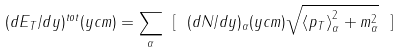Convert formula to latex. <formula><loc_0><loc_0><loc_500><loc_500>( d E _ { T } / d y ) ^ { t o t } ( y c m ) = \sum _ { \alpha } \ [ \ ( d N / d y ) _ { \alpha } ( y c m ) \sqrt { \left \langle p _ { T } \right \rangle _ { \alpha } ^ { 2 } + m _ { \alpha } ^ { 2 } } \ ]</formula> 